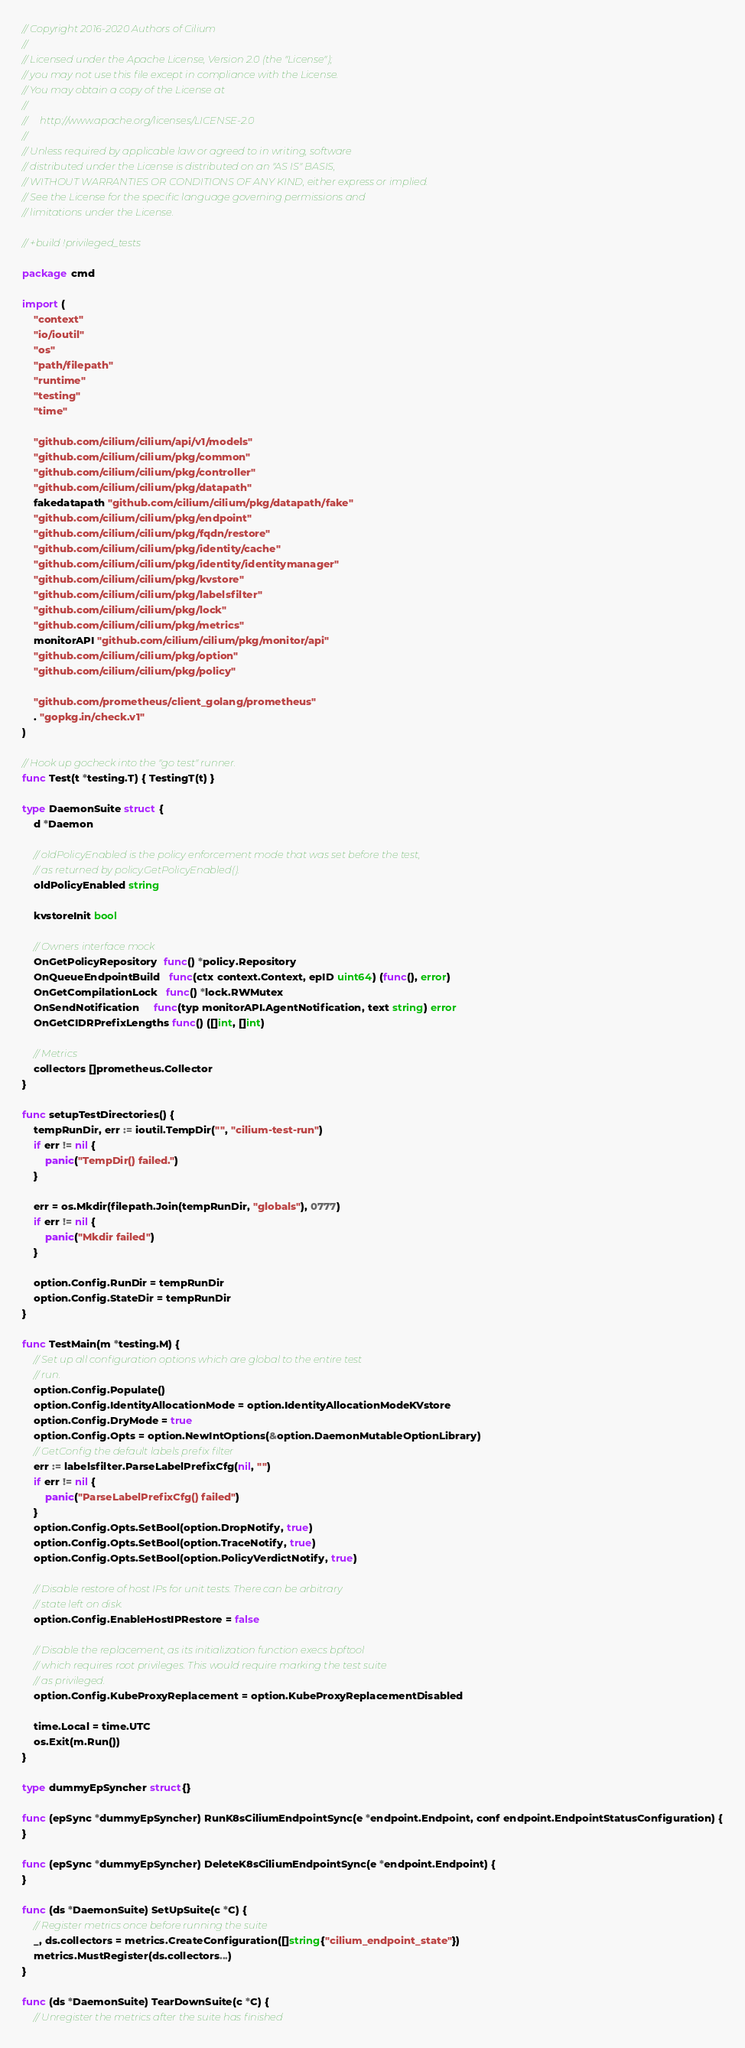Convert code to text. <code><loc_0><loc_0><loc_500><loc_500><_Go_>// Copyright 2016-2020 Authors of Cilium
//
// Licensed under the Apache License, Version 2.0 (the "License");
// you may not use this file except in compliance with the License.
// You may obtain a copy of the License at
//
//     http://www.apache.org/licenses/LICENSE-2.0
//
// Unless required by applicable law or agreed to in writing, software
// distributed under the License is distributed on an "AS IS" BASIS,
// WITHOUT WARRANTIES OR CONDITIONS OF ANY KIND, either express or implied.
// See the License for the specific language governing permissions and
// limitations under the License.

// +build !privileged_tests

package cmd

import (
	"context"
	"io/ioutil"
	"os"
	"path/filepath"
	"runtime"
	"testing"
	"time"

	"github.com/cilium/cilium/api/v1/models"
	"github.com/cilium/cilium/pkg/common"
	"github.com/cilium/cilium/pkg/controller"
	"github.com/cilium/cilium/pkg/datapath"
	fakedatapath "github.com/cilium/cilium/pkg/datapath/fake"
	"github.com/cilium/cilium/pkg/endpoint"
	"github.com/cilium/cilium/pkg/fqdn/restore"
	"github.com/cilium/cilium/pkg/identity/cache"
	"github.com/cilium/cilium/pkg/identity/identitymanager"
	"github.com/cilium/cilium/pkg/kvstore"
	"github.com/cilium/cilium/pkg/labelsfilter"
	"github.com/cilium/cilium/pkg/lock"
	"github.com/cilium/cilium/pkg/metrics"
	monitorAPI "github.com/cilium/cilium/pkg/monitor/api"
	"github.com/cilium/cilium/pkg/option"
	"github.com/cilium/cilium/pkg/policy"

	"github.com/prometheus/client_golang/prometheus"
	. "gopkg.in/check.v1"
)

// Hook up gocheck into the "go test" runner.
func Test(t *testing.T) { TestingT(t) }

type DaemonSuite struct {
	d *Daemon

	// oldPolicyEnabled is the policy enforcement mode that was set before the test,
	// as returned by policy.GetPolicyEnabled().
	oldPolicyEnabled string

	kvstoreInit bool

	// Owners interface mock
	OnGetPolicyRepository  func() *policy.Repository
	OnQueueEndpointBuild   func(ctx context.Context, epID uint64) (func(), error)
	OnGetCompilationLock   func() *lock.RWMutex
	OnSendNotification     func(typ monitorAPI.AgentNotification, text string) error
	OnGetCIDRPrefixLengths func() ([]int, []int)

	// Metrics
	collectors []prometheus.Collector
}

func setupTestDirectories() {
	tempRunDir, err := ioutil.TempDir("", "cilium-test-run")
	if err != nil {
		panic("TempDir() failed.")
	}

	err = os.Mkdir(filepath.Join(tempRunDir, "globals"), 0777)
	if err != nil {
		panic("Mkdir failed")
	}

	option.Config.RunDir = tempRunDir
	option.Config.StateDir = tempRunDir
}

func TestMain(m *testing.M) {
	// Set up all configuration options which are global to the entire test
	// run.
	option.Config.Populate()
	option.Config.IdentityAllocationMode = option.IdentityAllocationModeKVstore
	option.Config.DryMode = true
	option.Config.Opts = option.NewIntOptions(&option.DaemonMutableOptionLibrary)
	// GetConfig the default labels prefix filter
	err := labelsfilter.ParseLabelPrefixCfg(nil, "")
	if err != nil {
		panic("ParseLabelPrefixCfg() failed")
	}
	option.Config.Opts.SetBool(option.DropNotify, true)
	option.Config.Opts.SetBool(option.TraceNotify, true)
	option.Config.Opts.SetBool(option.PolicyVerdictNotify, true)

	// Disable restore of host IPs for unit tests. There can be arbitrary
	// state left on disk.
	option.Config.EnableHostIPRestore = false

	// Disable the replacement, as its initialization function execs bpftool
	// which requires root privileges. This would require marking the test suite
	// as privileged.
	option.Config.KubeProxyReplacement = option.KubeProxyReplacementDisabled

	time.Local = time.UTC
	os.Exit(m.Run())
}

type dummyEpSyncher struct{}

func (epSync *dummyEpSyncher) RunK8sCiliumEndpointSync(e *endpoint.Endpoint, conf endpoint.EndpointStatusConfiguration) {
}

func (epSync *dummyEpSyncher) DeleteK8sCiliumEndpointSync(e *endpoint.Endpoint) {
}

func (ds *DaemonSuite) SetUpSuite(c *C) {
	// Register metrics once before running the suite
	_, ds.collectors = metrics.CreateConfiguration([]string{"cilium_endpoint_state"})
	metrics.MustRegister(ds.collectors...)
}

func (ds *DaemonSuite) TearDownSuite(c *C) {
	// Unregister the metrics after the suite has finished</code> 